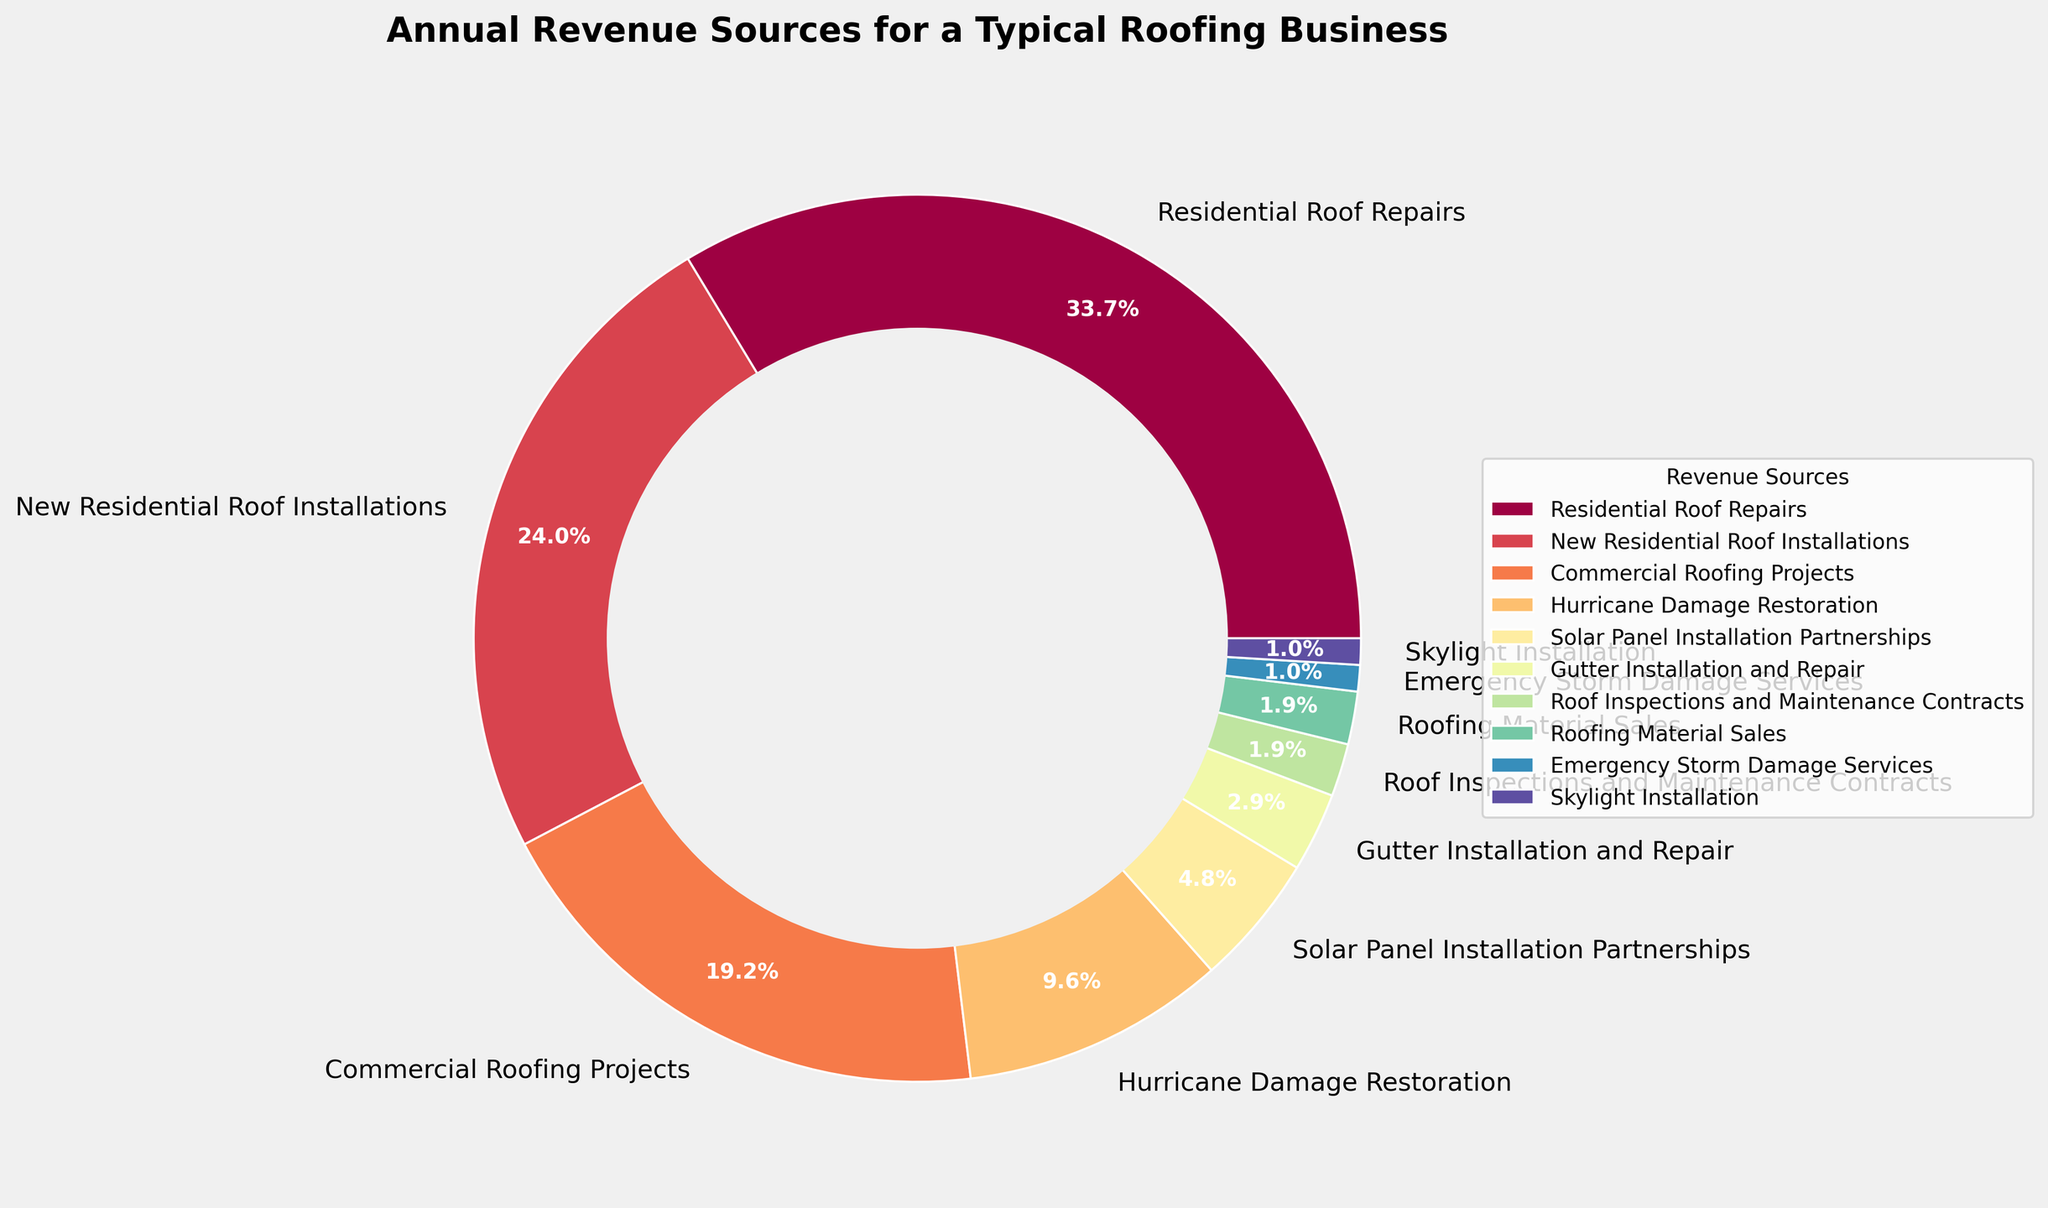What's the largest revenue source for the roofing business? Identify the segment with the highest percentage in the pie chart. The largest segment corresponds to 'Residential Roof Repairs' with 35%.
Answer: Residential Roof Repairs What's the combined percentage of revenue from Residential Roof Repairs and New Residential Roof Installations? Sum the percentages of 'Residential Roof Repairs' and 'New Residential Roof Installations' from the pie chart. 35% (Residential Roof Repairs) + 25% (New Residential Roof Installations) = 60%.
Answer: 60% How does the revenue from Commercial Roofing Projects compare to that from Hurricane Damage Restoration? Look at the pie chart to find the percentages for 'Commercial Roofing Projects' and 'Hurricane Damage Restoration'. 'Commercial Roofing Projects' has 20% and 'Hurricane Damage Restoration' has 10%. 20% is greater than 10%.
Answer: Commercial Roofing Projects has more revenue What is the percentage difference between Solar Panel Installation Partnerships and Gutter Installation and Repair? Subtract the percentage of 'Gutter Installation and Repair' from 'Solar Panel Installation Partnerships'. 5% (Solar Panel Installation Partnerships) - 3% (Gutter Installation and Repair) = 2%.
Answer: 2% What percentage of overall revenue comes from services other than Residential Roof Repairs and New Residential Roof Installations? Subtract the percentages of 'Residential Roof Repairs' and 'New Residential Roof Installations' from 100%. 100% - 35% (Residential Roof Repairs) - 25% (New Residential Roof Installations) = 40%.
Answer: 40% Which revenue sources contribute equally to the business? Look for segments in the pie chart that have the same percentage. 'Roof Inspections and Maintenance Contracts' and 'Roofing Material Sales' both contribute 2%. 'Emergency Storm Damage Services' and 'Skylight Installation' both contribute 1%.
Answer: Roof Inspections and Maintenance Contracts, Roofing Material Sales; Emergency Storm Damage Services, Skylight Installation What's the combined revenue percentage of the smallest three categories? Identify and sum up the smallest three percentages. 'Emergency Storm Damage Services' (1%) + 'Skylight Installation' (1%) + 'Roof Inspections and Maintenance Contracts' (2%) = 4%.
Answer: 4% What is the least contributing revenue source to the business? Identify the smallest segment in the pie chart. The smallest segment is 'Emergency Storm Damage Services' and 'Skylight Installation', both contribute 1%.
Answer: Emergency Storm Damage Services and Skylight Installation How much greater is the revenue from Residential Roof Repairs compared to Gutter Installation and Repair? Subtract the percentage of 'Gutter Installation and Repair' from 'Residential Roof Repairs'. 35% (Residential Roof Repairs) - 3% (Gutter Installation and Repair) = 32%.
Answer: 32% 